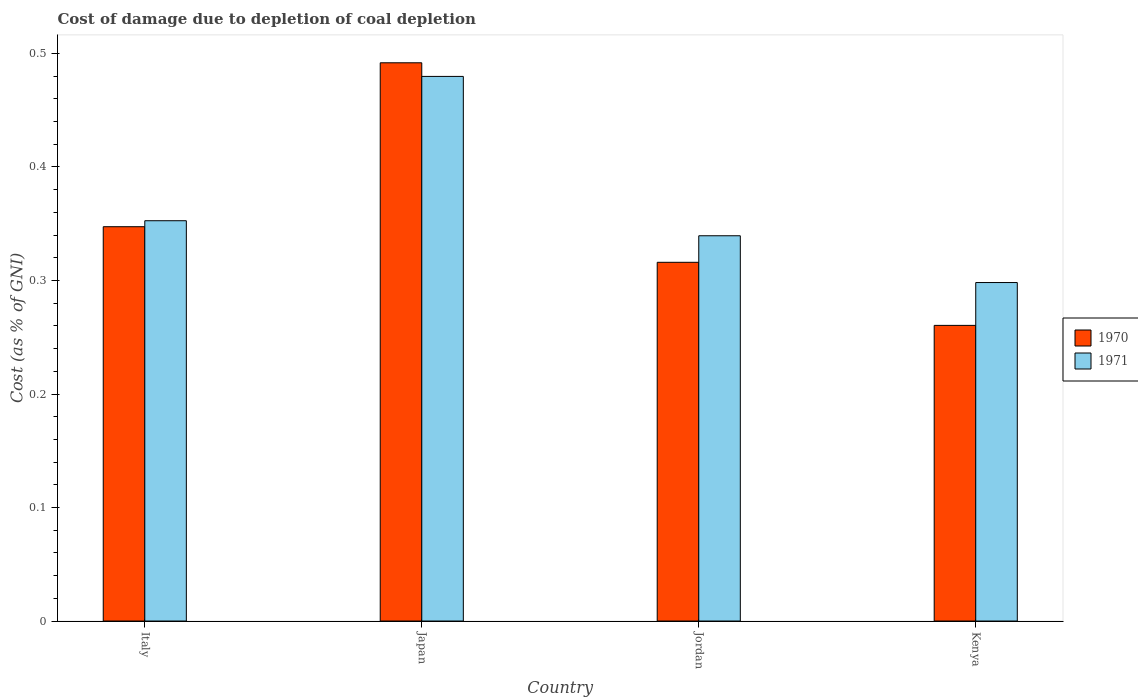How many groups of bars are there?
Offer a terse response. 4. Are the number of bars per tick equal to the number of legend labels?
Give a very brief answer. Yes. Are the number of bars on each tick of the X-axis equal?
Make the answer very short. Yes. How many bars are there on the 4th tick from the left?
Make the answer very short. 2. What is the label of the 1st group of bars from the left?
Keep it short and to the point. Italy. What is the cost of damage caused due to coal depletion in 1971 in Italy?
Offer a very short reply. 0.35. Across all countries, what is the maximum cost of damage caused due to coal depletion in 1971?
Keep it short and to the point. 0.48. Across all countries, what is the minimum cost of damage caused due to coal depletion in 1971?
Offer a terse response. 0.3. In which country was the cost of damage caused due to coal depletion in 1970 minimum?
Provide a short and direct response. Kenya. What is the total cost of damage caused due to coal depletion in 1970 in the graph?
Give a very brief answer. 1.42. What is the difference between the cost of damage caused due to coal depletion in 1971 in Italy and that in Japan?
Give a very brief answer. -0.13. What is the difference between the cost of damage caused due to coal depletion in 1971 in Italy and the cost of damage caused due to coal depletion in 1970 in Japan?
Your response must be concise. -0.14. What is the average cost of damage caused due to coal depletion in 1971 per country?
Ensure brevity in your answer.  0.37. What is the difference between the cost of damage caused due to coal depletion of/in 1970 and cost of damage caused due to coal depletion of/in 1971 in Japan?
Make the answer very short. 0.01. In how many countries, is the cost of damage caused due to coal depletion in 1970 greater than 0.46 %?
Ensure brevity in your answer.  1. What is the ratio of the cost of damage caused due to coal depletion in 1970 in Italy to that in Japan?
Make the answer very short. 0.71. Is the difference between the cost of damage caused due to coal depletion in 1970 in Japan and Jordan greater than the difference between the cost of damage caused due to coal depletion in 1971 in Japan and Jordan?
Provide a succinct answer. Yes. What is the difference between the highest and the second highest cost of damage caused due to coal depletion in 1970?
Give a very brief answer. 0.14. What is the difference between the highest and the lowest cost of damage caused due to coal depletion in 1970?
Provide a short and direct response. 0.23. In how many countries, is the cost of damage caused due to coal depletion in 1971 greater than the average cost of damage caused due to coal depletion in 1971 taken over all countries?
Your response must be concise. 1. Is the sum of the cost of damage caused due to coal depletion in 1970 in Italy and Japan greater than the maximum cost of damage caused due to coal depletion in 1971 across all countries?
Offer a very short reply. Yes. Are all the bars in the graph horizontal?
Your answer should be very brief. No. Are the values on the major ticks of Y-axis written in scientific E-notation?
Provide a short and direct response. No. Where does the legend appear in the graph?
Your answer should be very brief. Center right. How are the legend labels stacked?
Ensure brevity in your answer.  Vertical. What is the title of the graph?
Give a very brief answer. Cost of damage due to depletion of coal depletion. Does "1968" appear as one of the legend labels in the graph?
Provide a succinct answer. No. What is the label or title of the X-axis?
Your response must be concise. Country. What is the label or title of the Y-axis?
Your answer should be compact. Cost (as % of GNI). What is the Cost (as % of GNI) in 1970 in Italy?
Your answer should be very brief. 0.35. What is the Cost (as % of GNI) of 1971 in Italy?
Your answer should be compact. 0.35. What is the Cost (as % of GNI) of 1970 in Japan?
Keep it short and to the point. 0.49. What is the Cost (as % of GNI) in 1971 in Japan?
Provide a succinct answer. 0.48. What is the Cost (as % of GNI) of 1970 in Jordan?
Keep it short and to the point. 0.32. What is the Cost (as % of GNI) in 1971 in Jordan?
Provide a succinct answer. 0.34. What is the Cost (as % of GNI) in 1970 in Kenya?
Offer a terse response. 0.26. What is the Cost (as % of GNI) of 1971 in Kenya?
Offer a very short reply. 0.3. Across all countries, what is the maximum Cost (as % of GNI) in 1970?
Your answer should be very brief. 0.49. Across all countries, what is the maximum Cost (as % of GNI) of 1971?
Ensure brevity in your answer.  0.48. Across all countries, what is the minimum Cost (as % of GNI) in 1970?
Your answer should be very brief. 0.26. Across all countries, what is the minimum Cost (as % of GNI) of 1971?
Give a very brief answer. 0.3. What is the total Cost (as % of GNI) of 1970 in the graph?
Your response must be concise. 1.42. What is the total Cost (as % of GNI) in 1971 in the graph?
Provide a short and direct response. 1.47. What is the difference between the Cost (as % of GNI) of 1970 in Italy and that in Japan?
Provide a succinct answer. -0.14. What is the difference between the Cost (as % of GNI) of 1971 in Italy and that in Japan?
Your response must be concise. -0.13. What is the difference between the Cost (as % of GNI) in 1970 in Italy and that in Jordan?
Offer a terse response. 0.03. What is the difference between the Cost (as % of GNI) in 1971 in Italy and that in Jordan?
Provide a short and direct response. 0.01. What is the difference between the Cost (as % of GNI) of 1970 in Italy and that in Kenya?
Ensure brevity in your answer.  0.09. What is the difference between the Cost (as % of GNI) in 1971 in Italy and that in Kenya?
Give a very brief answer. 0.05. What is the difference between the Cost (as % of GNI) of 1970 in Japan and that in Jordan?
Provide a succinct answer. 0.18. What is the difference between the Cost (as % of GNI) in 1971 in Japan and that in Jordan?
Your answer should be compact. 0.14. What is the difference between the Cost (as % of GNI) of 1970 in Japan and that in Kenya?
Keep it short and to the point. 0.23. What is the difference between the Cost (as % of GNI) in 1971 in Japan and that in Kenya?
Make the answer very short. 0.18. What is the difference between the Cost (as % of GNI) of 1970 in Jordan and that in Kenya?
Offer a very short reply. 0.06. What is the difference between the Cost (as % of GNI) in 1971 in Jordan and that in Kenya?
Offer a terse response. 0.04. What is the difference between the Cost (as % of GNI) in 1970 in Italy and the Cost (as % of GNI) in 1971 in Japan?
Offer a very short reply. -0.13. What is the difference between the Cost (as % of GNI) of 1970 in Italy and the Cost (as % of GNI) of 1971 in Jordan?
Offer a very short reply. 0.01. What is the difference between the Cost (as % of GNI) of 1970 in Italy and the Cost (as % of GNI) of 1971 in Kenya?
Keep it short and to the point. 0.05. What is the difference between the Cost (as % of GNI) in 1970 in Japan and the Cost (as % of GNI) in 1971 in Jordan?
Make the answer very short. 0.15. What is the difference between the Cost (as % of GNI) in 1970 in Japan and the Cost (as % of GNI) in 1971 in Kenya?
Make the answer very short. 0.19. What is the difference between the Cost (as % of GNI) in 1970 in Jordan and the Cost (as % of GNI) in 1971 in Kenya?
Ensure brevity in your answer.  0.02. What is the average Cost (as % of GNI) of 1970 per country?
Your answer should be compact. 0.35. What is the average Cost (as % of GNI) in 1971 per country?
Provide a short and direct response. 0.37. What is the difference between the Cost (as % of GNI) in 1970 and Cost (as % of GNI) in 1971 in Italy?
Give a very brief answer. -0.01. What is the difference between the Cost (as % of GNI) of 1970 and Cost (as % of GNI) of 1971 in Japan?
Ensure brevity in your answer.  0.01. What is the difference between the Cost (as % of GNI) of 1970 and Cost (as % of GNI) of 1971 in Jordan?
Your answer should be very brief. -0.02. What is the difference between the Cost (as % of GNI) in 1970 and Cost (as % of GNI) in 1971 in Kenya?
Keep it short and to the point. -0.04. What is the ratio of the Cost (as % of GNI) in 1970 in Italy to that in Japan?
Your response must be concise. 0.71. What is the ratio of the Cost (as % of GNI) of 1971 in Italy to that in Japan?
Offer a very short reply. 0.73. What is the ratio of the Cost (as % of GNI) in 1970 in Italy to that in Jordan?
Your answer should be compact. 1.1. What is the ratio of the Cost (as % of GNI) in 1971 in Italy to that in Jordan?
Give a very brief answer. 1.04. What is the ratio of the Cost (as % of GNI) of 1970 in Italy to that in Kenya?
Ensure brevity in your answer.  1.33. What is the ratio of the Cost (as % of GNI) of 1971 in Italy to that in Kenya?
Offer a very short reply. 1.18. What is the ratio of the Cost (as % of GNI) of 1970 in Japan to that in Jordan?
Give a very brief answer. 1.56. What is the ratio of the Cost (as % of GNI) in 1971 in Japan to that in Jordan?
Offer a very short reply. 1.41. What is the ratio of the Cost (as % of GNI) in 1970 in Japan to that in Kenya?
Your answer should be compact. 1.89. What is the ratio of the Cost (as % of GNI) in 1971 in Japan to that in Kenya?
Provide a short and direct response. 1.61. What is the ratio of the Cost (as % of GNI) of 1970 in Jordan to that in Kenya?
Keep it short and to the point. 1.21. What is the ratio of the Cost (as % of GNI) of 1971 in Jordan to that in Kenya?
Your answer should be very brief. 1.14. What is the difference between the highest and the second highest Cost (as % of GNI) in 1970?
Give a very brief answer. 0.14. What is the difference between the highest and the second highest Cost (as % of GNI) of 1971?
Keep it short and to the point. 0.13. What is the difference between the highest and the lowest Cost (as % of GNI) in 1970?
Give a very brief answer. 0.23. What is the difference between the highest and the lowest Cost (as % of GNI) of 1971?
Your answer should be compact. 0.18. 